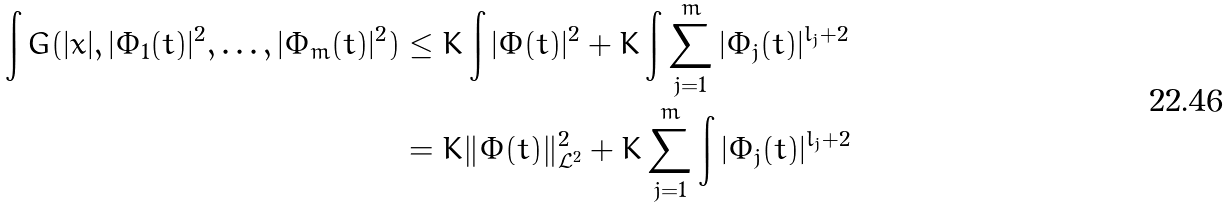<formula> <loc_0><loc_0><loc_500><loc_500>\int G ( | x | , | \Phi _ { 1 } ( t ) | ^ { 2 } , \dots , | \Phi _ { m } ( t ) | ^ { 2 } ) & \leq K \int | \Phi ( t ) | ^ { 2 } + K \int \sum _ { j = 1 } ^ { m } | \Phi _ { j } ( t ) | ^ { l _ { j } + 2 } \\ & = K \| \Phi ( t ) \| ^ { 2 } _ { \mathcal { L } ^ { 2 } } + K \sum _ { j = 1 } ^ { m } \int | \Phi _ { j } ( t ) | ^ { l _ { j } + 2 }</formula> 